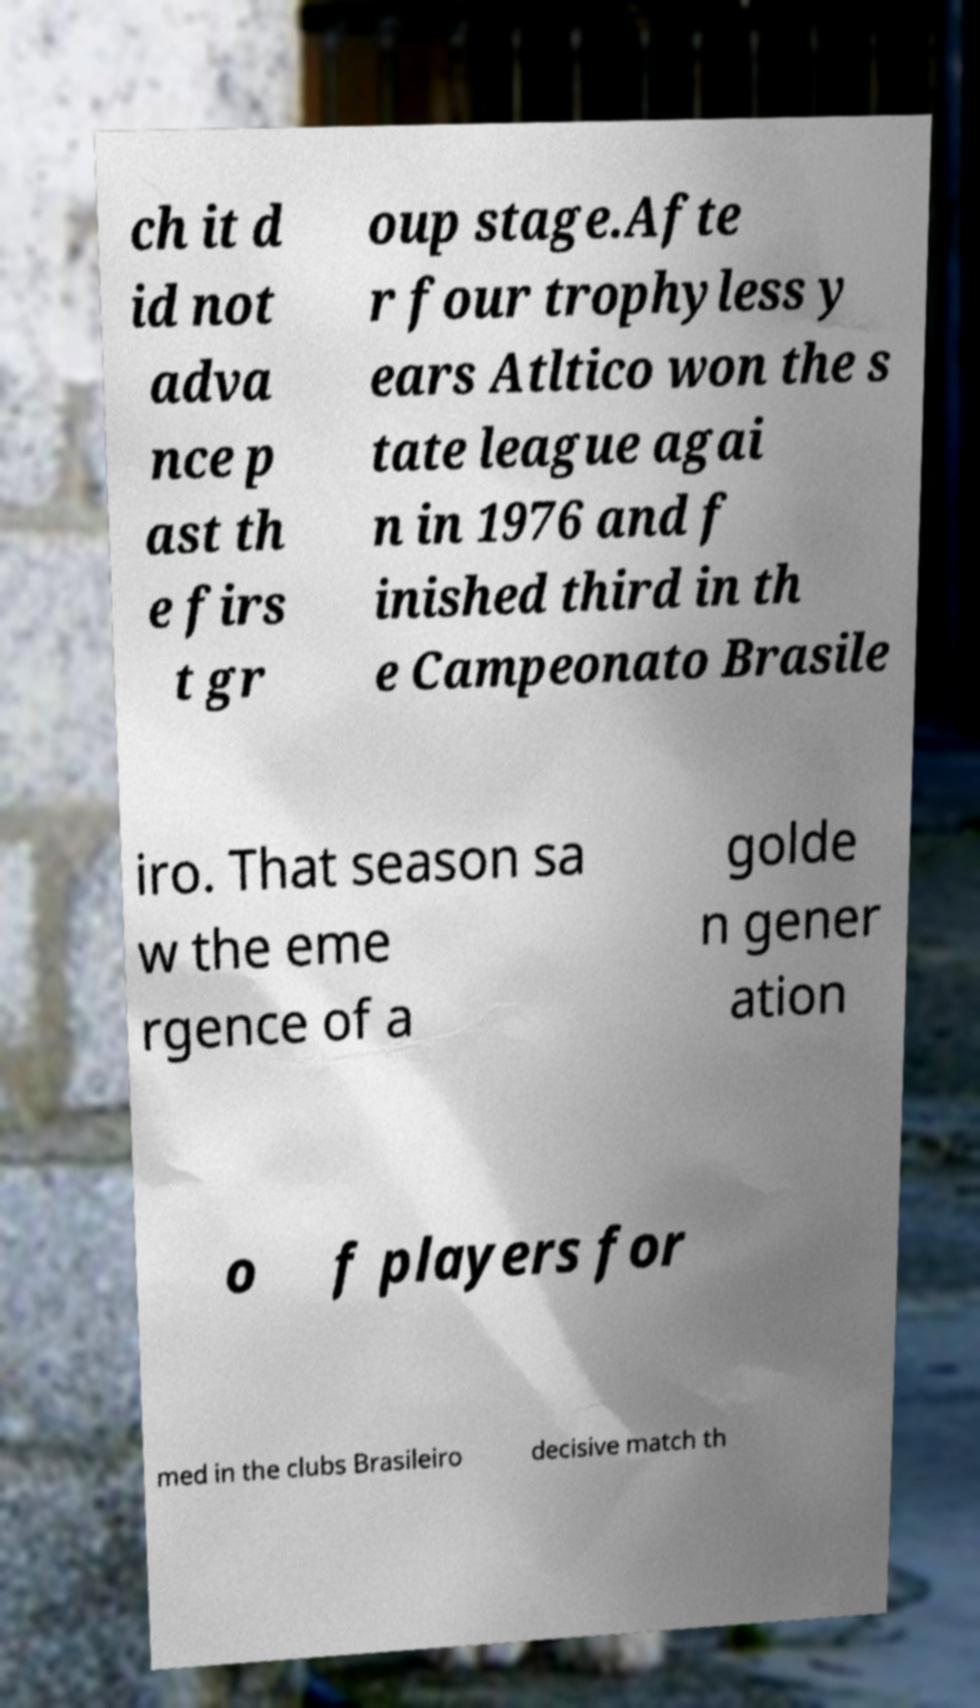Please identify and transcribe the text found in this image. ch it d id not adva nce p ast th e firs t gr oup stage.Afte r four trophyless y ears Atltico won the s tate league agai n in 1976 and f inished third in th e Campeonato Brasile iro. That season sa w the eme rgence of a golde n gener ation o f players for med in the clubs Brasileiro decisive match th 